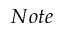Convert formula to latex. <formula><loc_0><loc_0><loc_500><loc_500>N o t e</formula> 